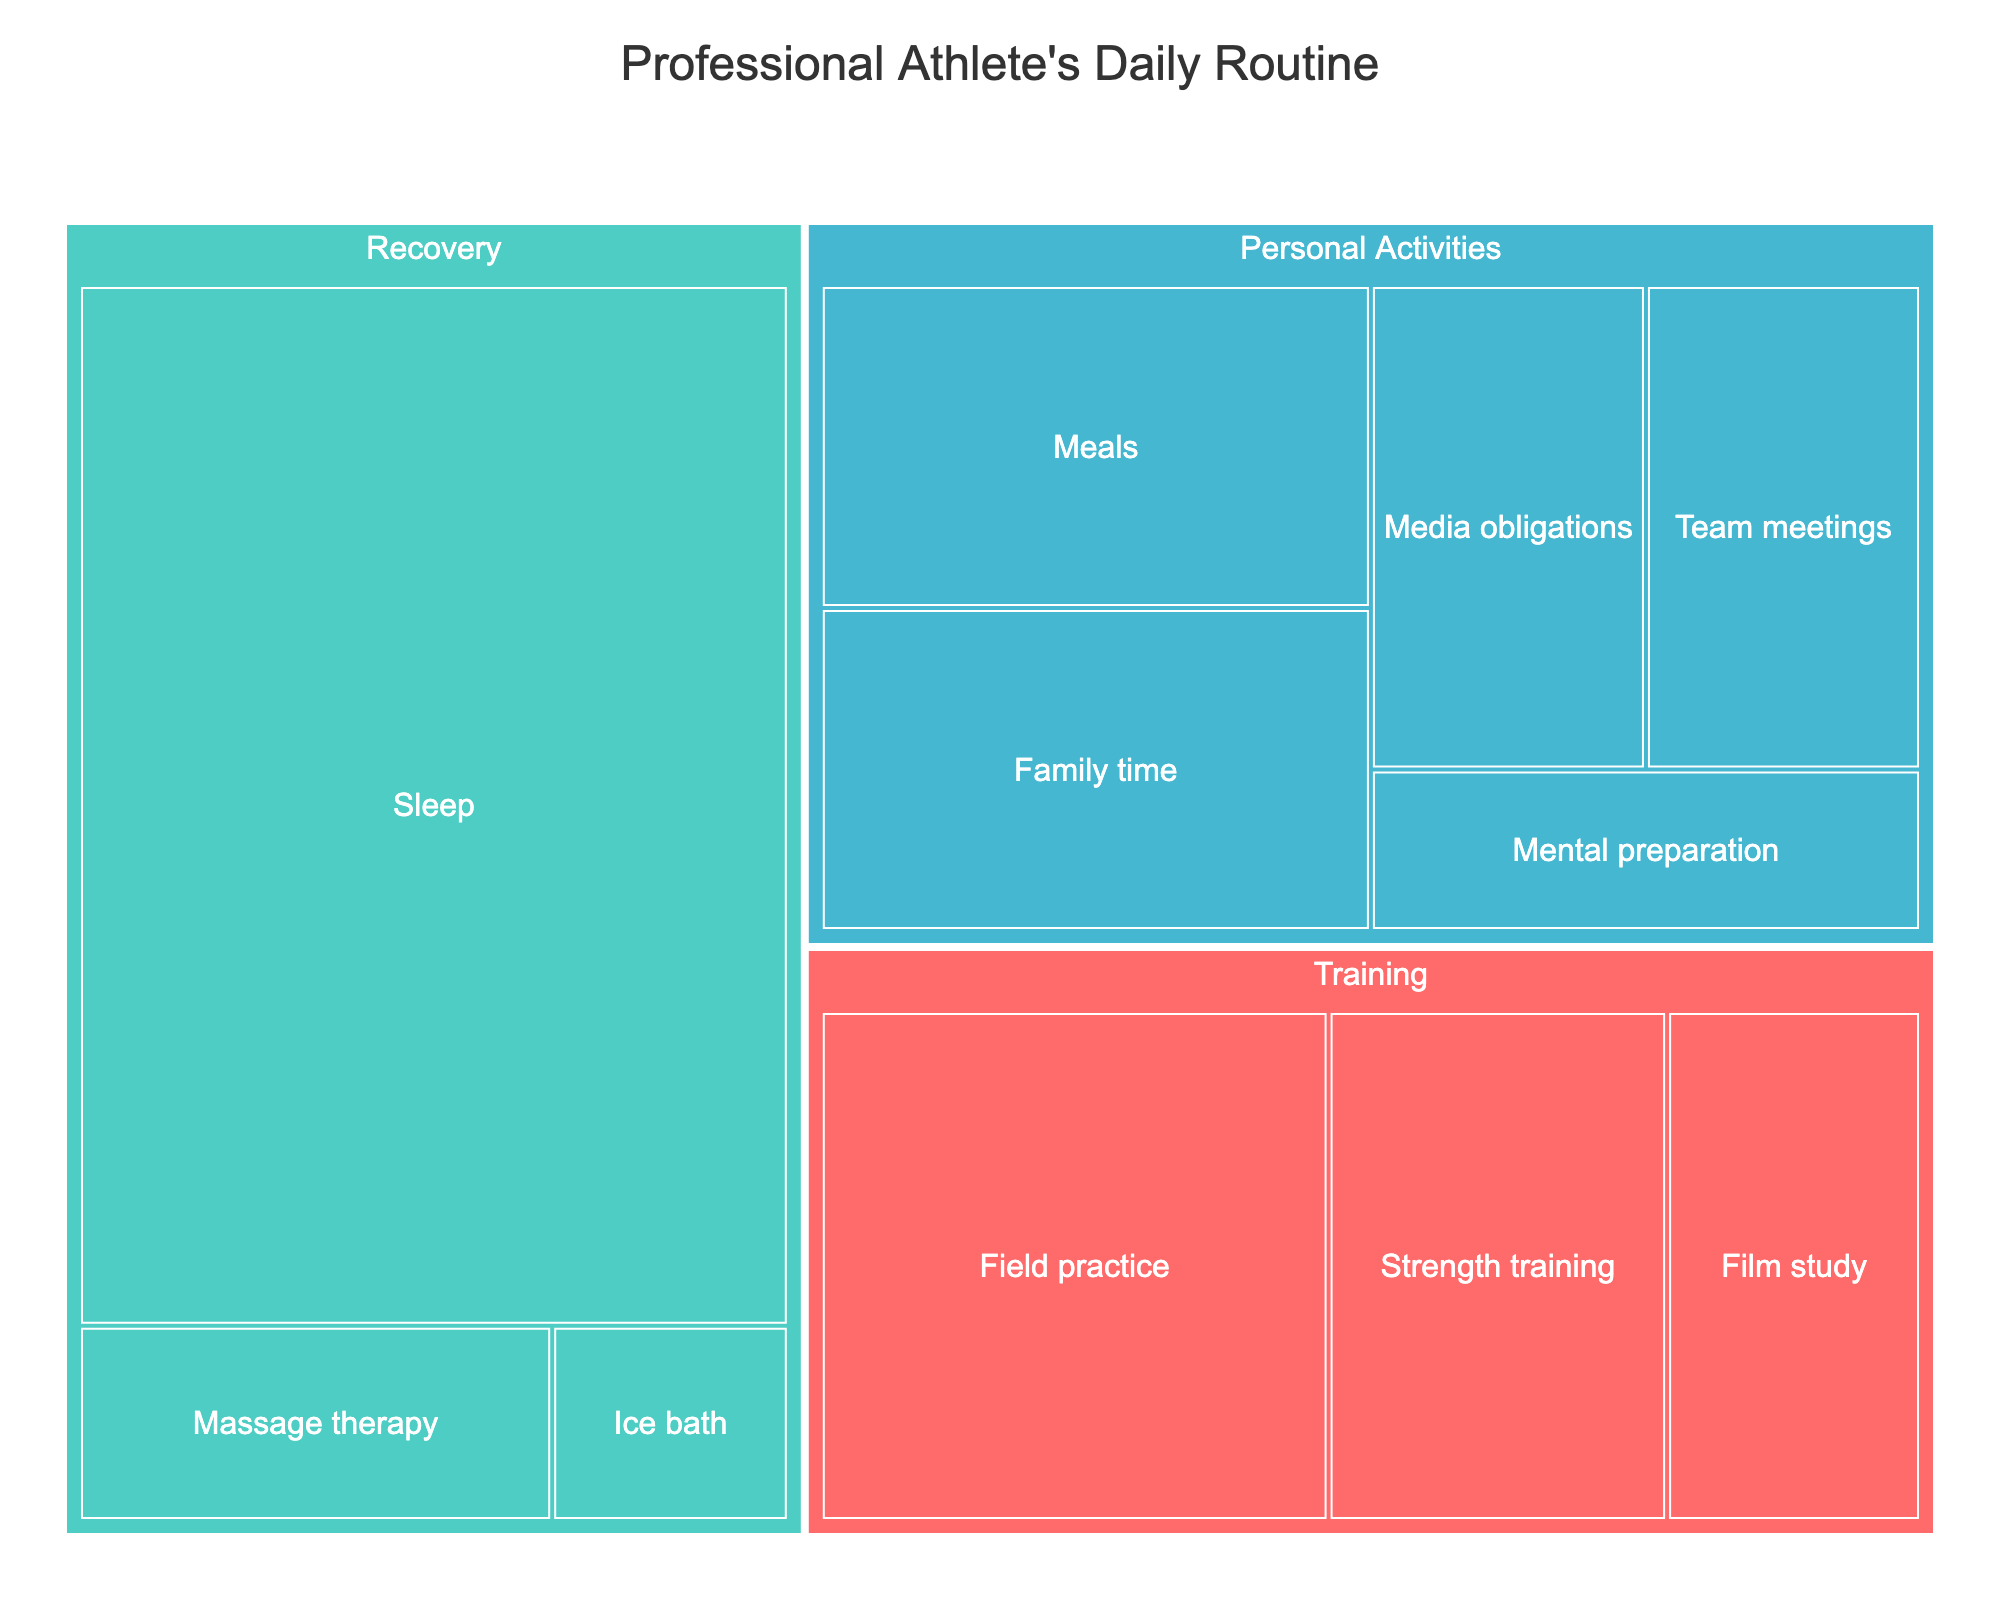How many hours are allocated to Training activities? To find the hours allocated to Training activities, sum up the hours for each subcategory under Training: Field practice (3), Strength training (2), and Film study (1.5). Thus, 3 + 2 + 1.5 = 6.5 hours are spent on Training activities.
Answer: 6.5 hours What portion of the day is spent on Personal Activities? Sum the hours for each subcategory under Personal Activities: Meals (2), Media obligations (1.5), Family time (2), Mental preparation (1), and Team meetings (1.5). Thus, 2 + 1.5 + 2 + 1 + 1.5 = 8 hours are spent on Personal Activities. Considering a 24-hour day, the portion spent on Personal Activities is 8/24, which is 1/3 or approximately 33.33%.
Answer: 33.33% Which category has the highest total time allocation? Comparing the total hours of each category, Training has 6.5 hours, Recovery has 9.5 hours (Sleep (8) + Massage therapy (1) + Ice bath (0.5)), and Personal Activities has 8 hours. Therefore, Recovery has the highest total time allocation.
Answer: Recovery Are more hours spent on Sleep or Field practice? The hours spent on Sleep are 8, while the hours spent on Field practice are 3. Since 8 (Sleep) is greater than 3 (Field practice), more hours are spent on Sleep.
Answer: Sleep How do the hours spent on Film study compare to those spent on Massage therapy? The hours spent on Film study are 1.5, while the hours spent on Massage therapy are 1. Since 1.5 (Film study) is greater than 1 (Massage therapy), more hours are spent on Film study.
Answer: Film study What is the smallest subcategory in terms of hours? The subcategories are Field practice (3), Strength training (2), Film study (1.5), Sleep (8), Massage therapy (1), Ice bath (0.5), Meals (2), Media obligations (1.5), Family time (2), Mental preparation (1), and Team meetings (1.5). The smallest subcategory in terms of hours is Ice bath with 0.5 hours.
Answer: Ice bath Which subcategory within Training occupies the most hours? Within Training, the subcategories are Field practice (3), Strength training (2), and Film study (1.5). Field practice has the highest number of hours at 3.
Answer: Field practice How much time is spent on Team meetings compared to Media obligations? The time spent on Team meetings is 1.5 hours, and the time spent on Media obligations is also 1.5 hours. Therefore, the time spent on Team meetings is equal to the time spent on Media obligations.
Answer: Equal What’s the total number of hours dedicated to Recovery activities? Sum the hours for each subcategory under Recovery: Sleep (8), Massage therapy (1), and Ice bath (0.5). Thus, 8 + 1 + 0.5 = 9.5 hours are dedicated to Recovery activities.
Answer: 9.5 hours 